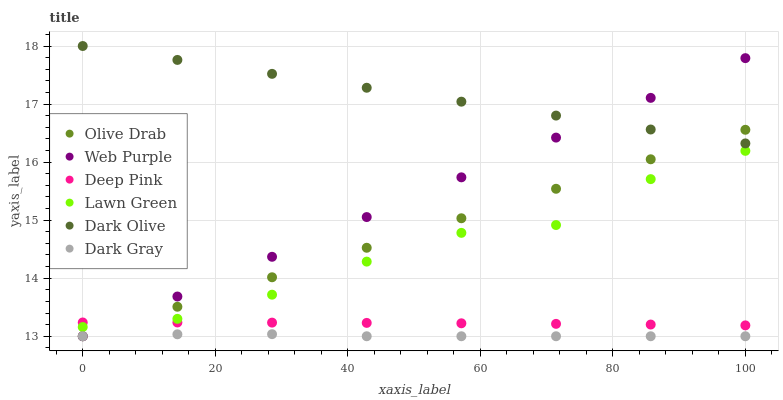Does Dark Gray have the minimum area under the curve?
Answer yes or no. Yes. Does Dark Olive have the maximum area under the curve?
Answer yes or no. Yes. Does Deep Pink have the minimum area under the curve?
Answer yes or no. No. Does Deep Pink have the maximum area under the curve?
Answer yes or no. No. Is Olive Drab the smoothest?
Answer yes or no. Yes. Is Lawn Green the roughest?
Answer yes or no. Yes. Is Deep Pink the smoothest?
Answer yes or no. No. Is Deep Pink the roughest?
Answer yes or no. No. Does Dark Gray have the lowest value?
Answer yes or no. Yes. Does Deep Pink have the lowest value?
Answer yes or no. No. Does Dark Olive have the highest value?
Answer yes or no. Yes. Does Deep Pink have the highest value?
Answer yes or no. No. Is Dark Gray less than Lawn Green?
Answer yes or no. Yes. Is Dark Olive greater than Dark Gray?
Answer yes or no. Yes. Does Olive Drab intersect Dark Olive?
Answer yes or no. Yes. Is Olive Drab less than Dark Olive?
Answer yes or no. No. Is Olive Drab greater than Dark Olive?
Answer yes or no. No. Does Dark Gray intersect Lawn Green?
Answer yes or no. No. 